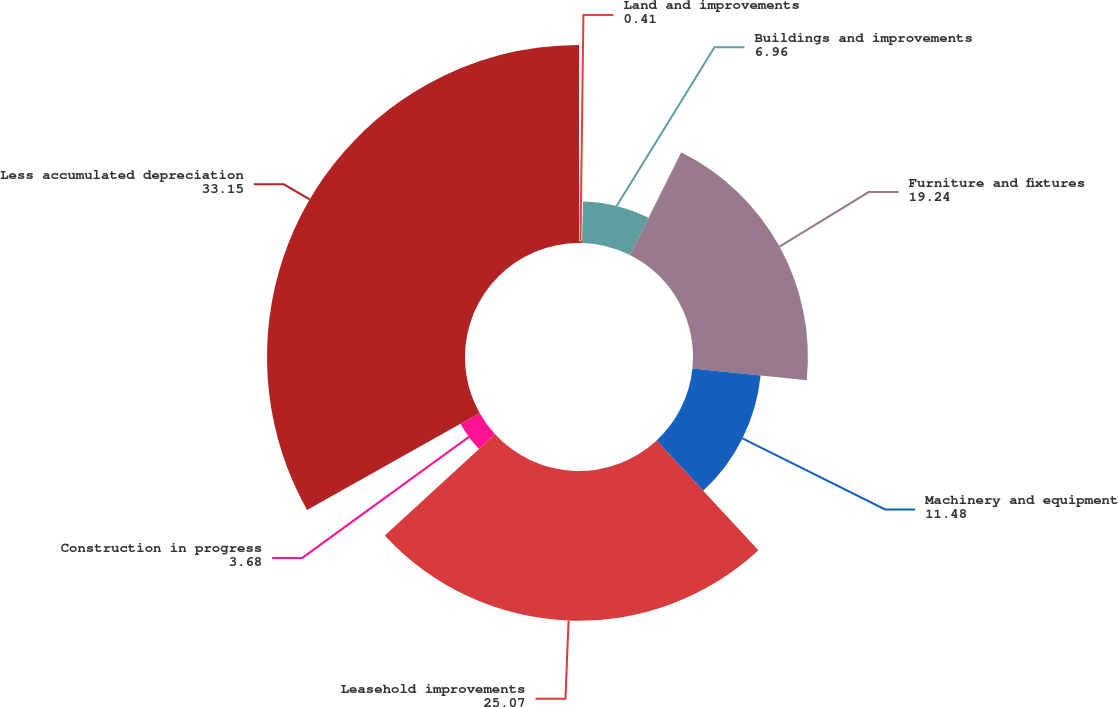Convert chart. <chart><loc_0><loc_0><loc_500><loc_500><pie_chart><fcel>Land and improvements<fcel>Buildings and improvements<fcel>Furniture and fixtures<fcel>Machinery and equipment<fcel>Leasehold improvements<fcel>Construction in progress<fcel>Less accumulated depreciation<nl><fcel>0.41%<fcel>6.96%<fcel>19.24%<fcel>11.48%<fcel>25.07%<fcel>3.68%<fcel>33.15%<nl></chart> 